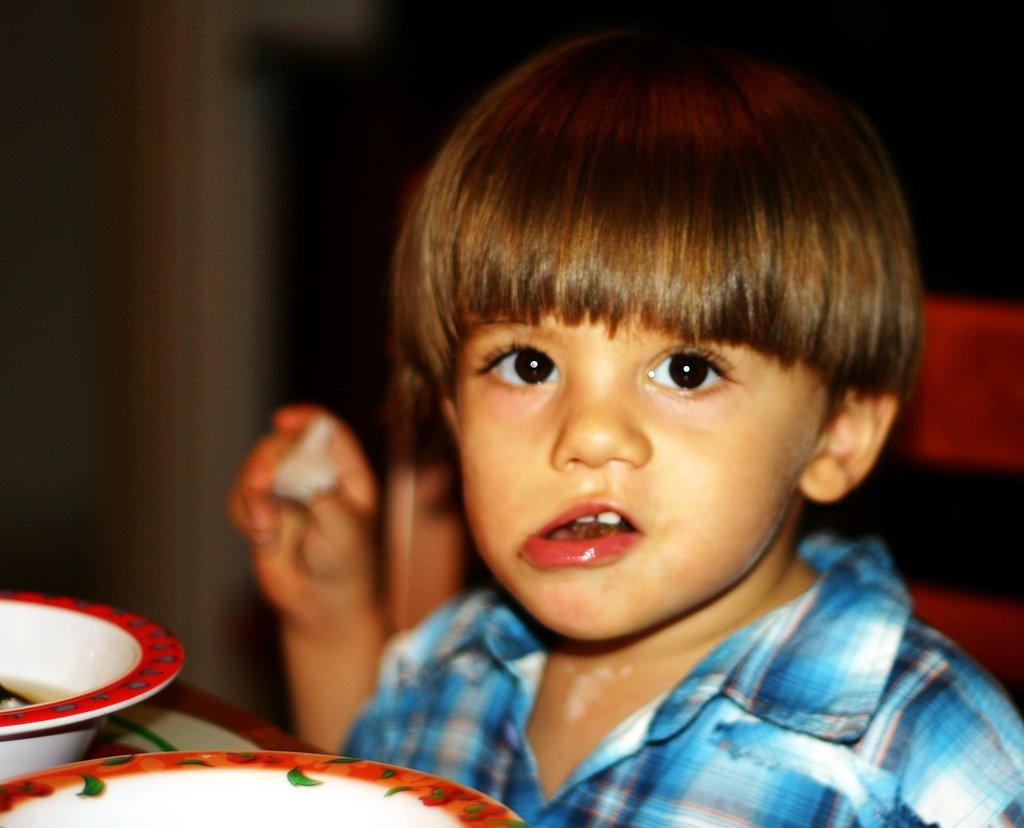Who is the main subject in the image? There is a boy in the image. What is the boy doing in the image? The boy is sitting on a chair. Where is the chair located in the image? The chair is at a table. What can be seen on the table in the image? There are bowls and a plate on the table. What invention is the boy holding in his hand in the image? There is no invention visible in the boy's hand in the image. What is the texture of the boy's finger in the image? The texture of the boy's finger cannot be determined from the image, as it is a two-dimensional representation. 